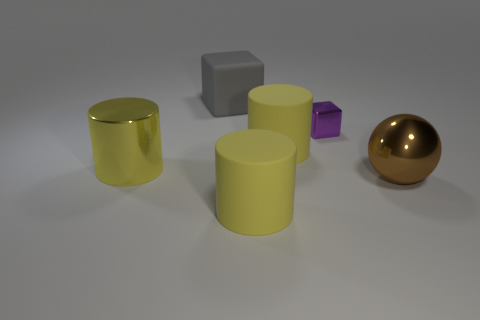Subtract all purple cylinders. Subtract all yellow balls. How many cylinders are left? 3 Add 2 large purple rubber spheres. How many objects exist? 8 Subtract all blocks. How many objects are left? 4 Add 6 large yellow cylinders. How many large yellow cylinders exist? 9 Subtract 0 purple spheres. How many objects are left? 6 Subtract all cubes. Subtract all yellow shiny objects. How many objects are left? 3 Add 1 small purple metal objects. How many small purple metal objects are left? 2 